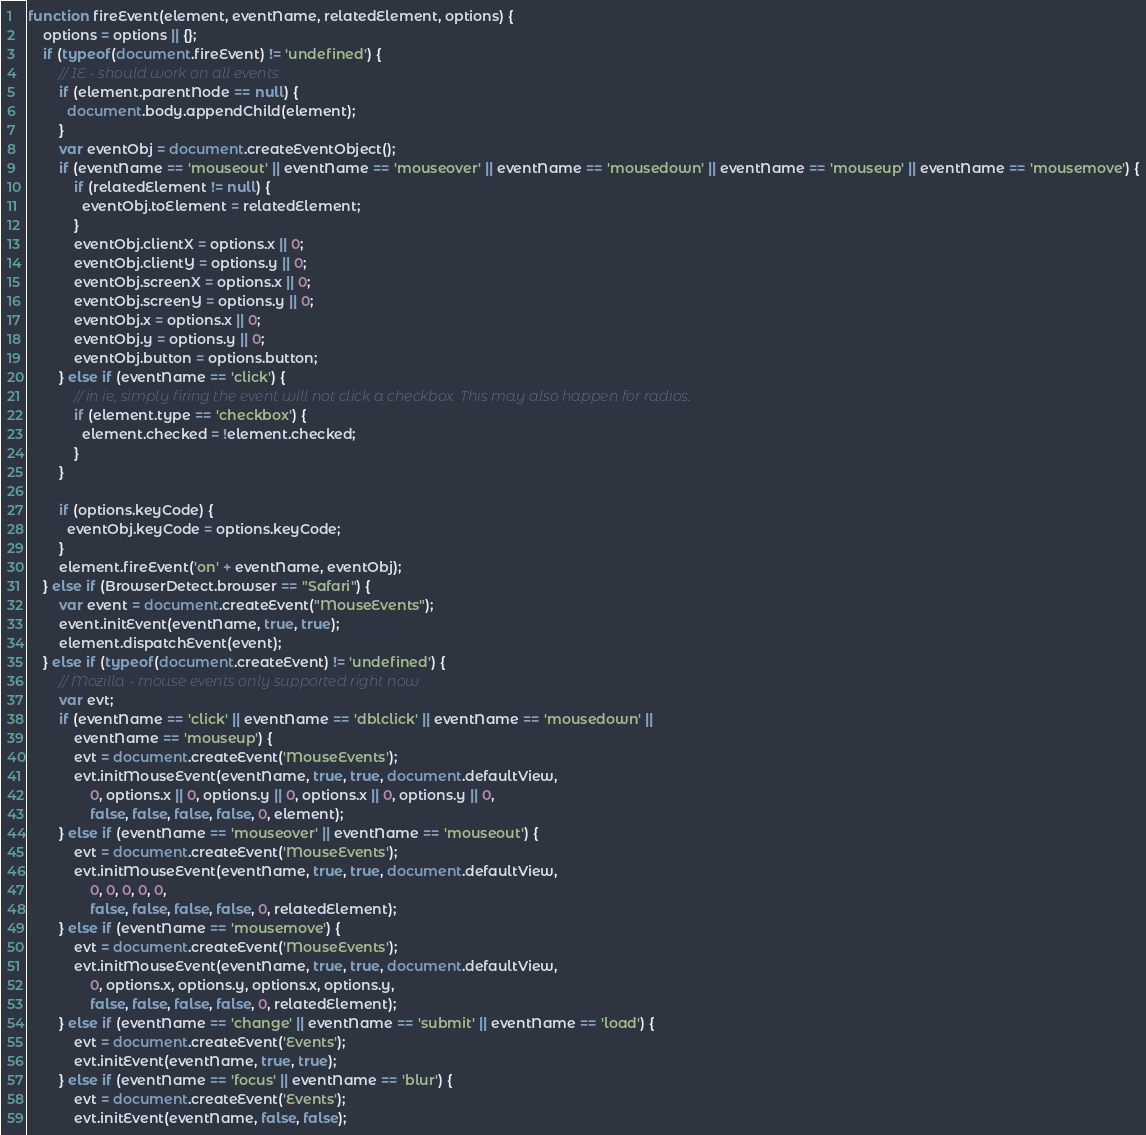<code> <loc_0><loc_0><loc_500><loc_500><_JavaScript_>function fireEvent(element, eventName, relatedElement, options) {
    options = options || {};
    if (typeof(document.fireEvent) != 'undefined') {
        // IE - should work on all events
        if (element.parentNode == null) {
          document.body.appendChild(element);
        }
        var eventObj = document.createEventObject();
        if (eventName == 'mouseout' || eventName == 'mouseover' || eventName == 'mousedown' || eventName == 'mouseup' || eventName == 'mousemove') {
            if (relatedElement != null) {
              eventObj.toElement = relatedElement;
            }
            eventObj.clientX = options.x || 0;
            eventObj.clientY = options.y || 0;
            eventObj.screenX = options.x || 0;
            eventObj.screenY = options.y || 0;
            eventObj.x = options.x || 0;
            eventObj.y = options.y || 0;
            eventObj.button = options.button;
        } else if (eventName == 'click') {
            // in ie, simply firing the event will not click a checkbox. This may also happen for radios.
            if (element.type == 'checkbox') {
              element.checked = !element.checked;
            }
        }

        if (options.keyCode) {
          eventObj.keyCode = options.keyCode;
        }
        element.fireEvent('on' + eventName, eventObj);
    } else if (BrowserDetect.browser == "Safari") {
        var event = document.createEvent("MouseEvents");
        event.initEvent(eventName, true, true);
        element.dispatchEvent(event);
    } else if (typeof(document.createEvent) != 'undefined') {
        // Mozilla - mouse events only supported right now
        var evt;
        if (eventName == 'click' || eventName == 'dblclick' || eventName == 'mousedown' || 
            eventName == 'mouseup') {
            evt = document.createEvent('MouseEvents');
            evt.initMouseEvent(eventName, true, true, document.defaultView,
                0, options.x || 0, options.y || 0, options.x || 0, options.y || 0,
                false, false, false, false, 0, element);
        } else if (eventName == 'mouseover' || eventName == 'mouseout') {
            evt = document.createEvent('MouseEvents');
            evt.initMouseEvent(eventName, true, true, document.defaultView,
                0, 0, 0, 0, 0,
                false, false, false, false, 0, relatedElement);
        } else if (eventName == 'mousemove') {
            evt = document.createEvent('MouseEvents');
            evt.initMouseEvent(eventName, true, true, document.defaultView,
                0, options.x, options.y, options.x, options.y,
                false, false, false, false, 0, relatedElement);
        } else if (eventName == 'change' || eventName == 'submit' || eventName == 'load') {
            evt = document.createEvent('Events');
            evt.initEvent(eventName, true, true);
        } else if (eventName == 'focus' || eventName == 'blur') {
            evt = document.createEvent('Events');
            evt.initEvent(eventName, false, false);</code> 